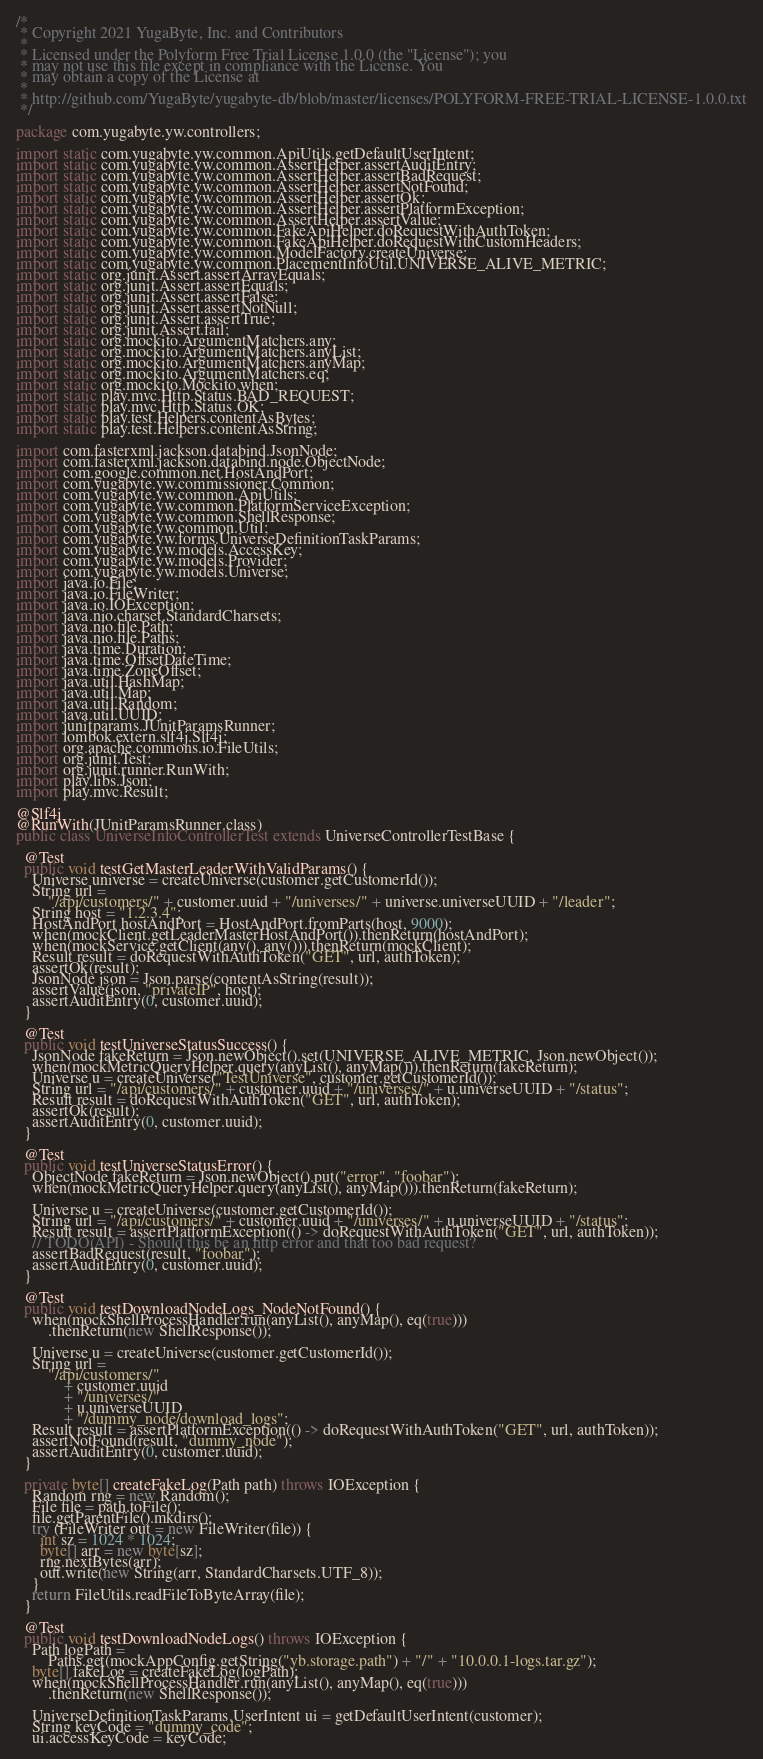Convert code to text. <code><loc_0><loc_0><loc_500><loc_500><_Java_>/*
 * Copyright 2021 YugaByte, Inc. and Contributors
 *
 * Licensed under the Polyform Free Trial License 1.0.0 (the "License"); you
 * may not use this file except in compliance with the License. You
 * may obtain a copy of the License at
 *
 * http://github.com/YugaByte/yugabyte-db/blob/master/licenses/POLYFORM-FREE-TRIAL-LICENSE-1.0.0.txt
 */

package com.yugabyte.yw.controllers;

import static com.yugabyte.yw.common.ApiUtils.getDefaultUserIntent;
import static com.yugabyte.yw.common.AssertHelper.assertAuditEntry;
import static com.yugabyte.yw.common.AssertHelper.assertBadRequest;
import static com.yugabyte.yw.common.AssertHelper.assertNotFound;
import static com.yugabyte.yw.common.AssertHelper.assertOk;
import static com.yugabyte.yw.common.AssertHelper.assertPlatformException;
import static com.yugabyte.yw.common.AssertHelper.assertValue;
import static com.yugabyte.yw.common.FakeApiHelper.doRequestWithAuthToken;
import static com.yugabyte.yw.common.FakeApiHelper.doRequestWithCustomHeaders;
import static com.yugabyte.yw.common.ModelFactory.createUniverse;
import static com.yugabyte.yw.common.PlacementInfoUtil.UNIVERSE_ALIVE_METRIC;
import static org.junit.Assert.assertArrayEquals;
import static org.junit.Assert.assertEquals;
import static org.junit.Assert.assertFalse;
import static org.junit.Assert.assertNotNull;
import static org.junit.Assert.assertTrue;
import static org.junit.Assert.fail;
import static org.mockito.ArgumentMatchers.any;
import static org.mockito.ArgumentMatchers.anyList;
import static org.mockito.ArgumentMatchers.anyMap;
import static org.mockito.ArgumentMatchers.eq;
import static org.mockito.Mockito.when;
import static play.mvc.Http.Status.BAD_REQUEST;
import static play.mvc.Http.Status.OK;
import static play.test.Helpers.contentAsBytes;
import static play.test.Helpers.contentAsString;

import com.fasterxml.jackson.databind.JsonNode;
import com.fasterxml.jackson.databind.node.ObjectNode;
import com.google.common.net.HostAndPort;
import com.yugabyte.yw.commissioner.Common;
import com.yugabyte.yw.common.ApiUtils;
import com.yugabyte.yw.common.PlatformServiceException;
import com.yugabyte.yw.common.ShellResponse;
import com.yugabyte.yw.common.Util;
import com.yugabyte.yw.forms.UniverseDefinitionTaskParams;
import com.yugabyte.yw.models.AccessKey;
import com.yugabyte.yw.models.Provider;
import com.yugabyte.yw.models.Universe;
import java.io.File;
import java.io.FileWriter;
import java.io.IOException;
import java.nio.charset.StandardCharsets;
import java.nio.file.Path;
import java.nio.file.Paths;
import java.time.Duration;
import java.time.OffsetDateTime;
import java.time.ZoneOffset;
import java.util.HashMap;
import java.util.Map;
import java.util.Random;
import java.util.UUID;
import junitparams.JUnitParamsRunner;
import lombok.extern.slf4j.Slf4j;
import org.apache.commons.io.FileUtils;
import org.junit.Test;
import org.junit.runner.RunWith;
import play.libs.Json;
import play.mvc.Result;

@Slf4j
@RunWith(JUnitParamsRunner.class)
public class UniverseInfoControllerTest extends UniverseControllerTestBase {

  @Test
  public void testGetMasterLeaderWithValidParams() {
    Universe universe = createUniverse(customer.getCustomerId());
    String url =
        "/api/customers/" + customer.uuid + "/universes/" + universe.universeUUID + "/leader";
    String host = "1.2.3.4";
    HostAndPort hostAndPort = HostAndPort.fromParts(host, 9000);
    when(mockClient.getLeaderMasterHostAndPort()).thenReturn(hostAndPort);
    when(mockService.getClient(any(), any())).thenReturn(mockClient);
    Result result = doRequestWithAuthToken("GET", url, authToken);
    assertOk(result);
    JsonNode json = Json.parse(contentAsString(result));
    assertValue(json, "privateIP", host);
    assertAuditEntry(0, customer.uuid);
  }

  @Test
  public void testUniverseStatusSuccess() {
    JsonNode fakeReturn = Json.newObject().set(UNIVERSE_ALIVE_METRIC, Json.newObject());
    when(mockMetricQueryHelper.query(anyList(), anyMap())).thenReturn(fakeReturn);
    Universe u = createUniverse("TestUniverse", customer.getCustomerId());
    String url = "/api/customers/" + customer.uuid + "/universes/" + u.universeUUID + "/status";
    Result result = doRequestWithAuthToken("GET", url, authToken);
    assertOk(result);
    assertAuditEntry(0, customer.uuid);
  }

  @Test
  public void testUniverseStatusError() {
    ObjectNode fakeReturn = Json.newObject().put("error", "foobar");
    when(mockMetricQueryHelper.query(anyList(), anyMap())).thenReturn(fakeReturn);

    Universe u = createUniverse(customer.getCustomerId());
    String url = "/api/customers/" + customer.uuid + "/universes/" + u.universeUUID + "/status";
    Result result = assertPlatformException(() -> doRequestWithAuthToken("GET", url, authToken));
    // TODO(API) - Should this be an http error and that too bad request?
    assertBadRequest(result, "foobar");
    assertAuditEntry(0, customer.uuid);
  }

  @Test
  public void testDownloadNodeLogs_NodeNotFound() {
    when(mockShellProcessHandler.run(anyList(), anyMap(), eq(true)))
        .thenReturn(new ShellResponse());

    Universe u = createUniverse(customer.getCustomerId());
    String url =
        "/api/customers/"
            + customer.uuid
            + "/universes/"
            + u.universeUUID
            + "/dummy_node/download_logs";
    Result result = assertPlatformException(() -> doRequestWithAuthToken("GET", url, authToken));
    assertNotFound(result, "dummy_node");
    assertAuditEntry(0, customer.uuid);
  }

  private byte[] createFakeLog(Path path) throws IOException {
    Random rng = new Random();
    File file = path.toFile();
    file.getParentFile().mkdirs();
    try (FileWriter out = new FileWriter(file)) {
      int sz = 1024 * 1024;
      byte[] arr = new byte[sz];
      rng.nextBytes(arr);
      out.write(new String(arr, StandardCharsets.UTF_8));
    }
    return FileUtils.readFileToByteArray(file);
  }

  @Test
  public void testDownloadNodeLogs() throws IOException {
    Path logPath =
        Paths.get(mockAppConfig.getString("yb.storage.path") + "/" + "10.0.0.1-logs.tar.gz");
    byte[] fakeLog = createFakeLog(logPath);
    when(mockShellProcessHandler.run(anyList(), anyMap(), eq(true)))
        .thenReturn(new ShellResponse());

    UniverseDefinitionTaskParams.UserIntent ui = getDefaultUserIntent(customer);
    String keyCode = "dummy_code";
    ui.accessKeyCode = keyCode;</code> 